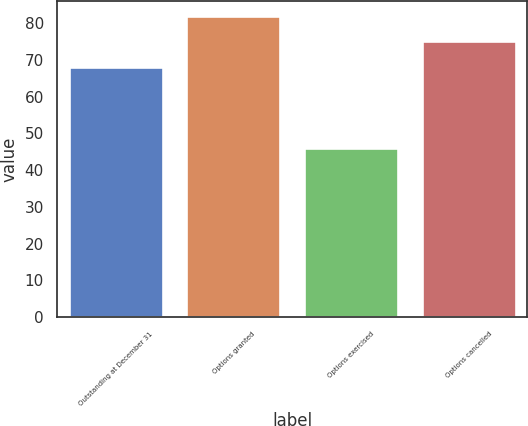Convert chart. <chart><loc_0><loc_0><loc_500><loc_500><bar_chart><fcel>Outstanding at December 31<fcel>Options granted<fcel>Options exercised<fcel>Options cancelled<nl><fcel>67.94<fcel>81.92<fcel>45.91<fcel>75.22<nl></chart> 